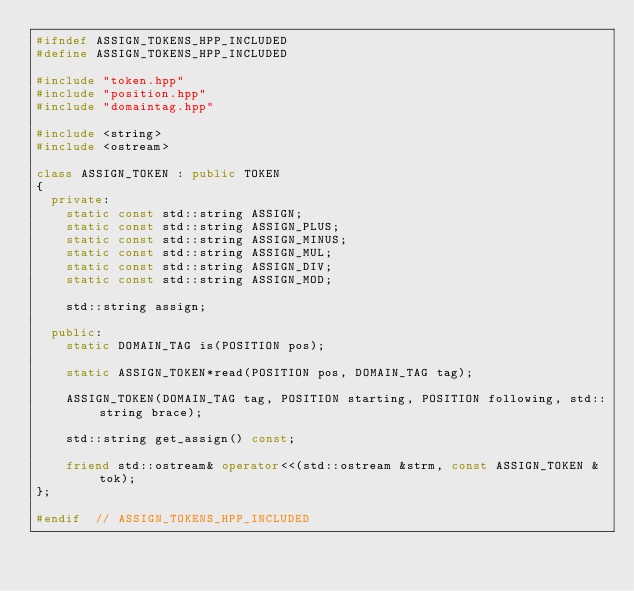<code> <loc_0><loc_0><loc_500><loc_500><_C++_>#ifndef ASSIGN_TOKENS_HPP_INCLUDED
#define ASSIGN_TOKENS_HPP_INCLUDED

#include "token.hpp"
#include "position.hpp"
#include "domaintag.hpp"

#include <string>
#include <ostream>

class ASSIGN_TOKEN : public TOKEN
{
  private:
    static const std::string ASSIGN;
    static const std::string ASSIGN_PLUS;
    static const std::string ASSIGN_MINUS;
    static const std::string ASSIGN_MUL;
    static const std::string ASSIGN_DIV;
    static const std::string ASSIGN_MOD;
    
    std::string assign;
    
  public:
    static DOMAIN_TAG is(POSITION pos);
    
    static ASSIGN_TOKEN*read(POSITION pos, DOMAIN_TAG tag);
    
    ASSIGN_TOKEN(DOMAIN_TAG tag, POSITION starting, POSITION following, std::string brace);

    std::string get_assign() const;

    friend std::ostream& operator<<(std::ostream &strm, const ASSIGN_TOKEN &tok);
};

#endif  // ASSIGN_TOKENS_HPP_INCLUDED
</code> 